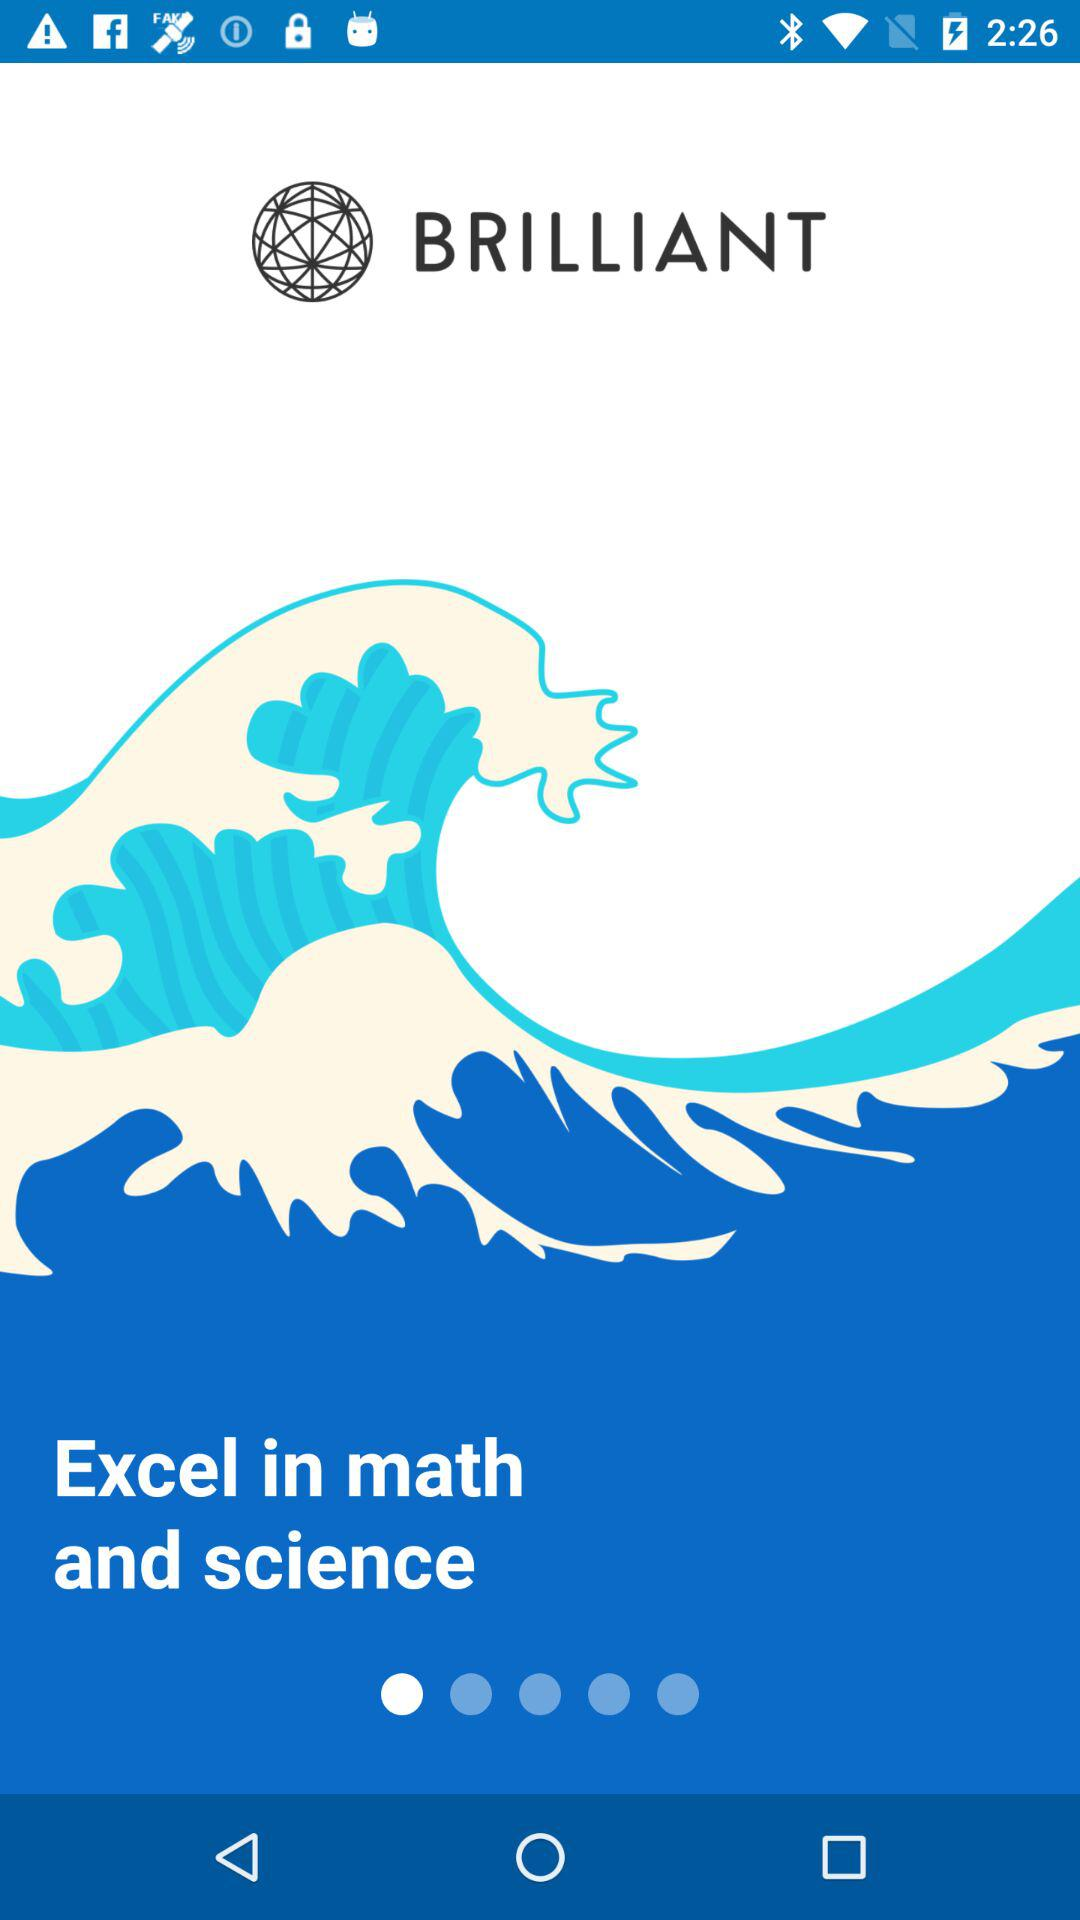What is the name of the application? The name of the application is "BRILLIANT". 